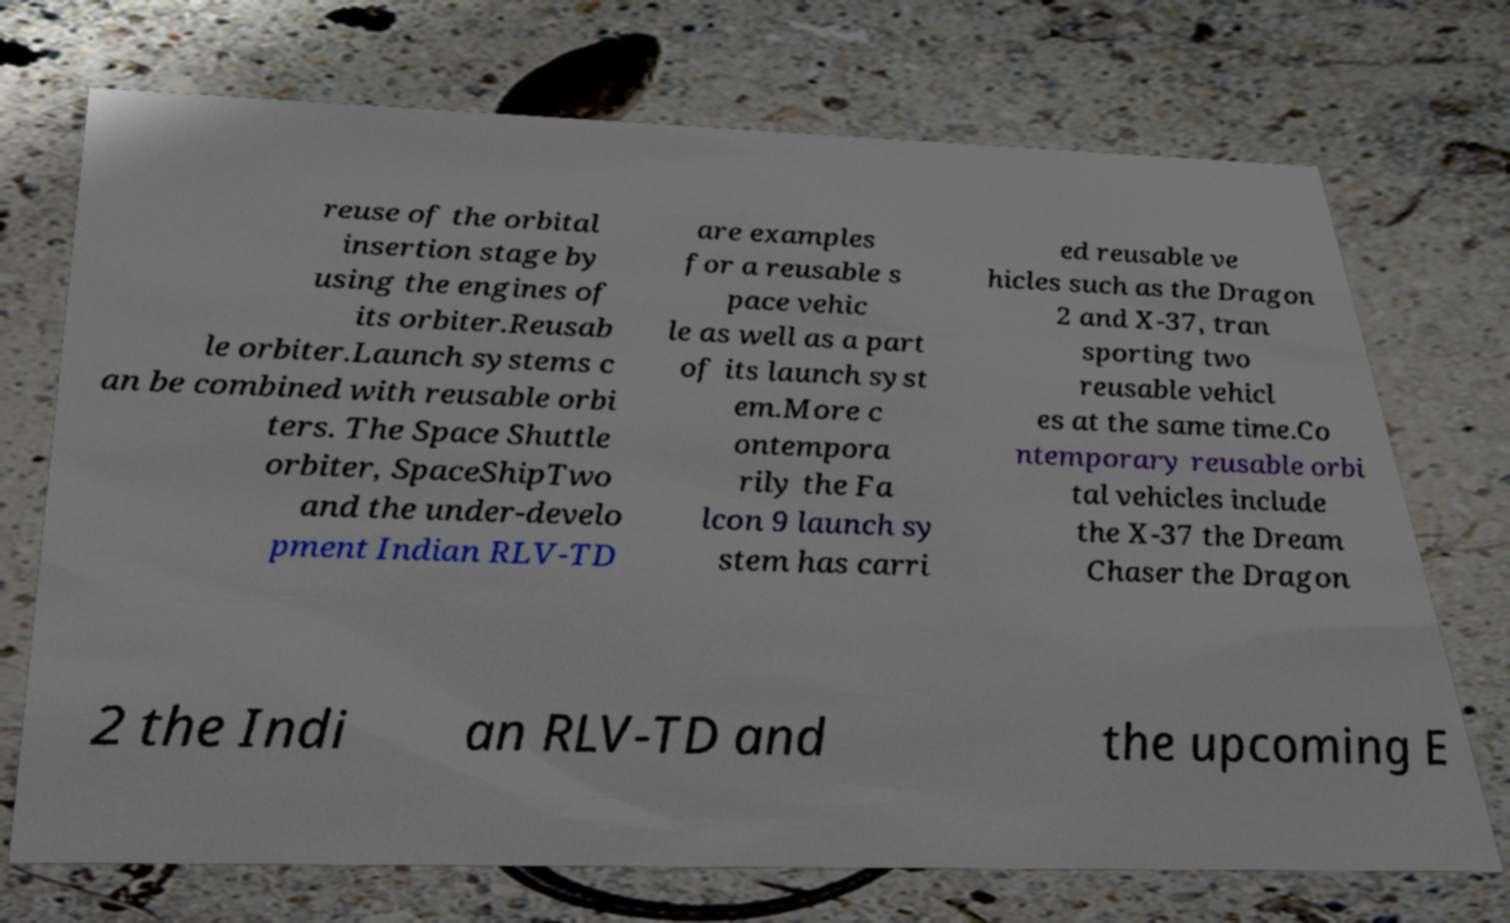Could you assist in decoding the text presented in this image and type it out clearly? reuse of the orbital insertion stage by using the engines of its orbiter.Reusab le orbiter.Launch systems c an be combined with reusable orbi ters. The Space Shuttle orbiter, SpaceShipTwo and the under-develo pment Indian RLV-TD are examples for a reusable s pace vehic le as well as a part of its launch syst em.More c ontempora rily the Fa lcon 9 launch sy stem has carri ed reusable ve hicles such as the Dragon 2 and X-37, tran sporting two reusable vehicl es at the same time.Co ntemporary reusable orbi tal vehicles include the X-37 the Dream Chaser the Dragon 2 the Indi an RLV-TD and the upcoming E 